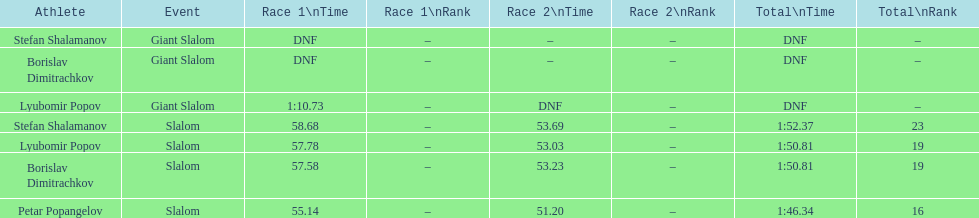Which athlete had a race time above 1:00? Lyubomir Popov. 